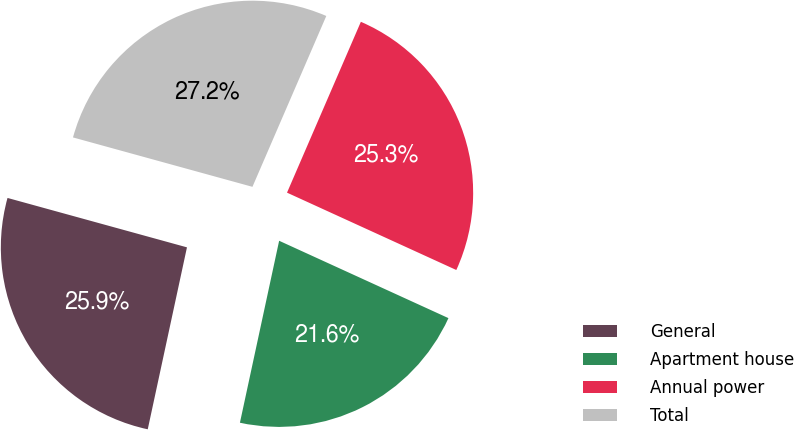Convert chart to OTSL. <chart><loc_0><loc_0><loc_500><loc_500><pie_chart><fcel>General<fcel>Apartment house<fcel>Annual power<fcel>Total<nl><fcel>25.9%<fcel>21.56%<fcel>25.33%<fcel>27.22%<nl></chart> 